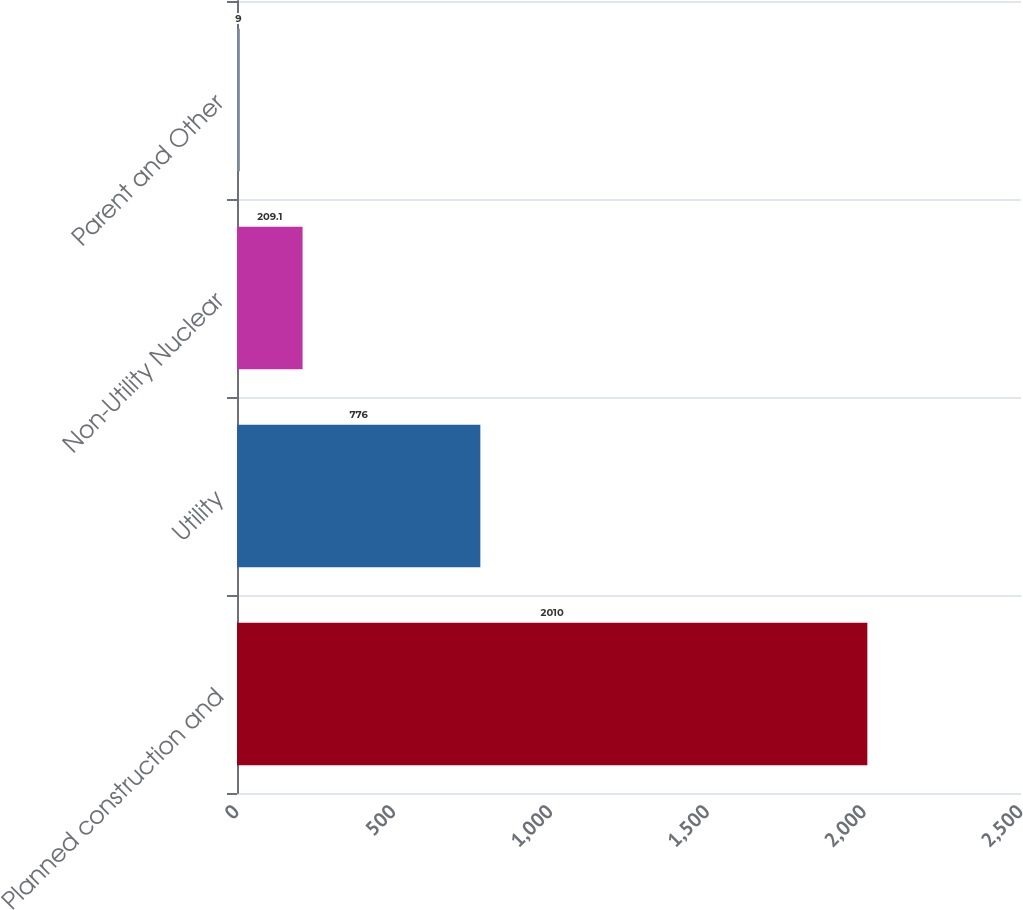Convert chart to OTSL. <chart><loc_0><loc_0><loc_500><loc_500><bar_chart><fcel>Planned construction and<fcel>Utility<fcel>Non-Utility Nuclear<fcel>Parent and Other<nl><fcel>2010<fcel>776<fcel>209.1<fcel>9<nl></chart> 